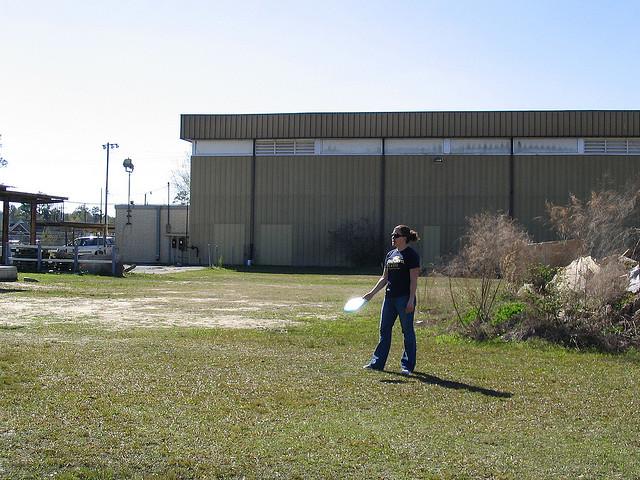Is sunlight reflecting off the frisbee?
Short answer required. Yes. What is the man holding in his right hand?
Quick response, please. Frisbee. Approximately what time of day is it based on the length of the woman's shadow?
Be succinct. 4 pm. 